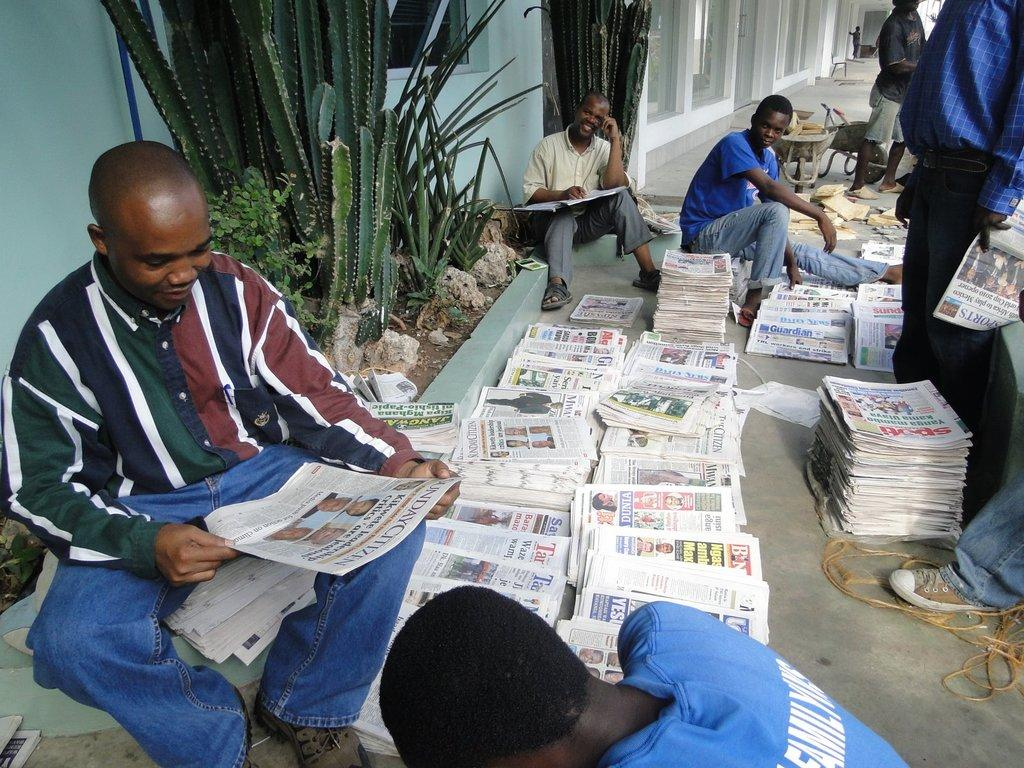What type of living organisms can be seen in the image? Plants are visible in the image. Are there any human subjects in the image? Yes, there are people in the image. What can be used for reading in the image? Newspapers are present in the image. What object can be used for tying or securing in the image? There is a rope in the image. What are the unspecified "things" in the image? Unfortunately, the facts provided do not specify what these "things" are. What type of structure is visible in the image? There is a wall in the image. What type of transparent material is present in the image? Glass windows are visible in the image. How many crates are stacked next to the people in the image? There is no crate present in the image. What type of birds are roaming around the plants in the image? There are no birds, specifically chickens, present in the image. 